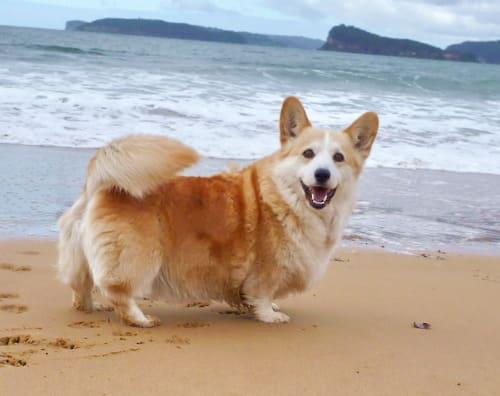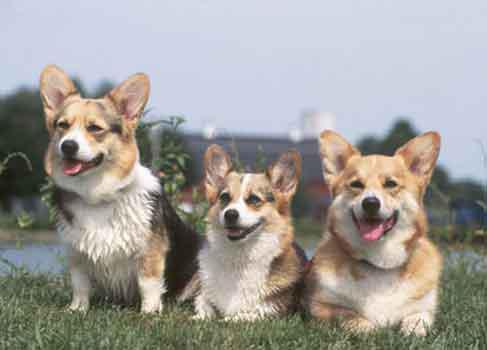The first image is the image on the left, the second image is the image on the right. Evaluate the accuracy of this statement regarding the images: "The dog in the image on the left is standing in the grass.". Is it true? Answer yes or no. No. The first image is the image on the left, the second image is the image on the right. Analyze the images presented: Is the assertion "Each image contains exactly one orange-and-white corgi, and at least one of the dogs pictured stands on all fours on green grass." valid? Answer yes or no. No. 